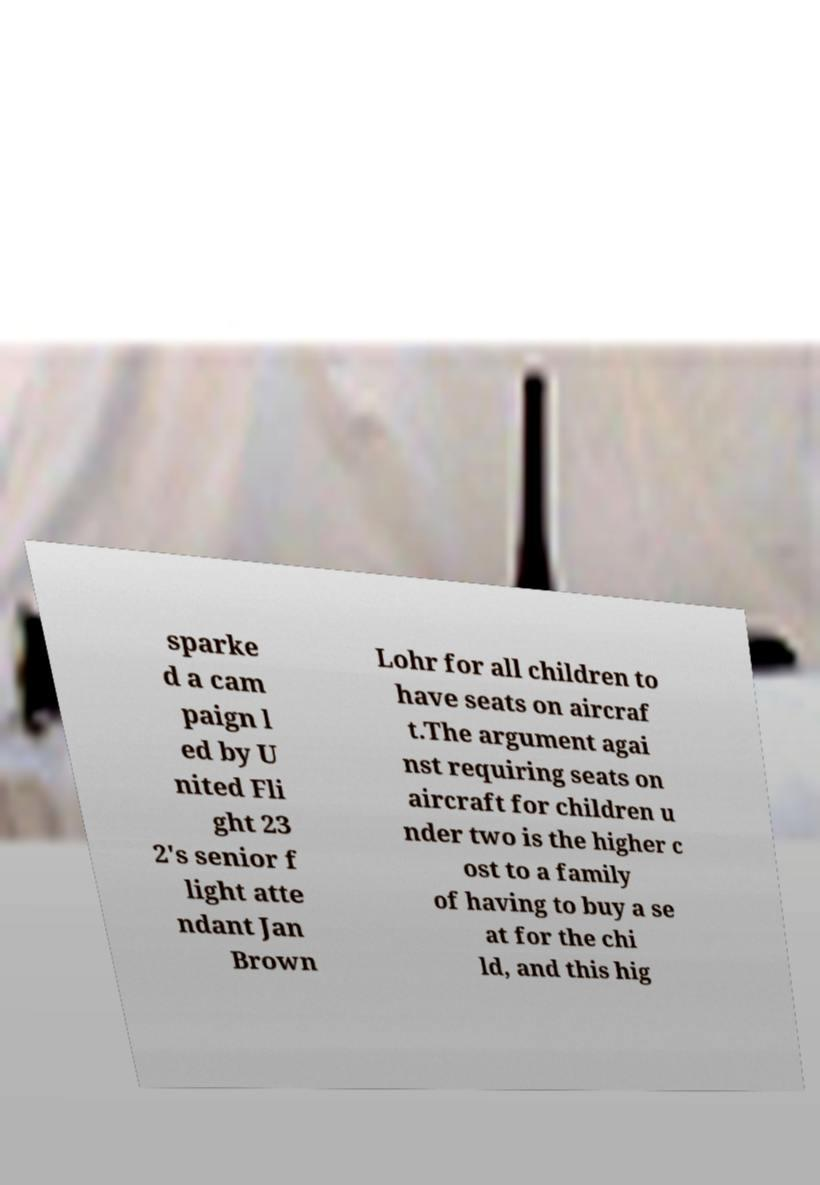Could you extract and type out the text from this image? sparke d a cam paign l ed by U nited Fli ght 23 2's senior f light atte ndant Jan Brown Lohr for all children to have seats on aircraf t.The argument agai nst requiring seats on aircraft for children u nder two is the higher c ost to a family of having to buy a se at for the chi ld, and this hig 